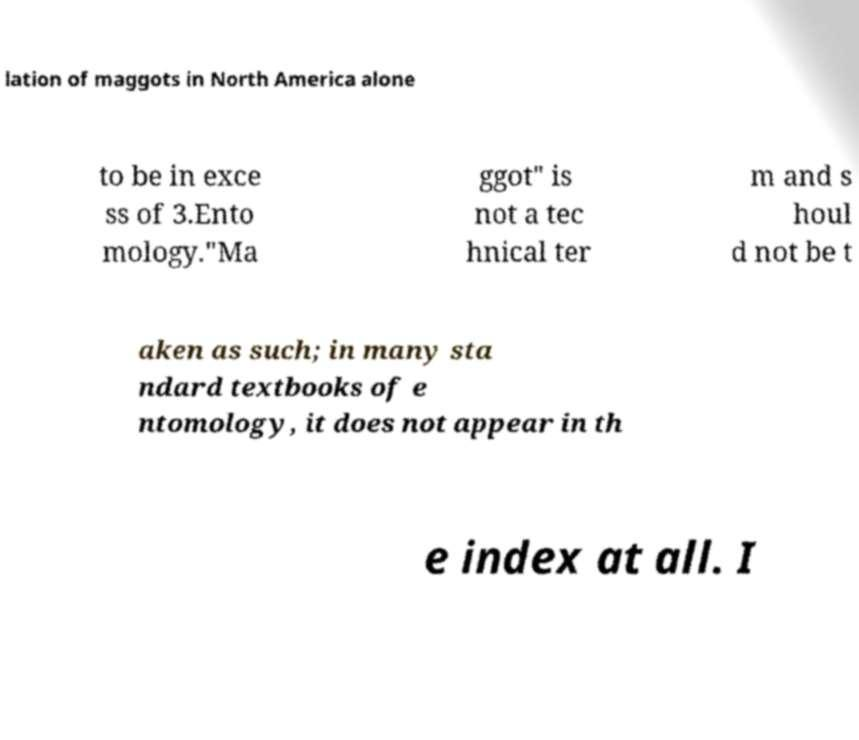Could you assist in decoding the text presented in this image and type it out clearly? lation of maggots in North America alone to be in exce ss of 3.Ento mology."Ma ggot" is not a tec hnical ter m and s houl d not be t aken as such; in many sta ndard textbooks of e ntomology, it does not appear in th e index at all. I 